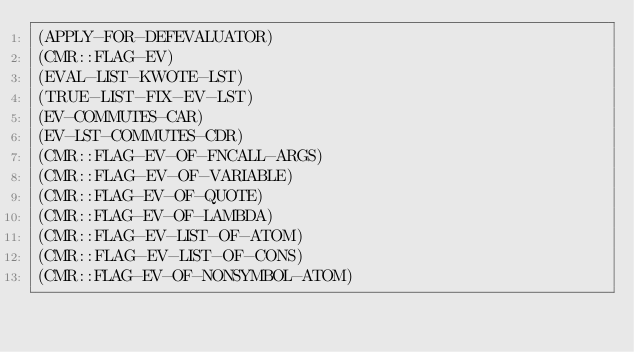<code> <loc_0><loc_0><loc_500><loc_500><_Lisp_>(APPLY-FOR-DEFEVALUATOR)
(CMR::FLAG-EV)
(EVAL-LIST-KWOTE-LST)
(TRUE-LIST-FIX-EV-LST)
(EV-COMMUTES-CAR)
(EV-LST-COMMUTES-CDR)
(CMR::FLAG-EV-OF-FNCALL-ARGS)
(CMR::FLAG-EV-OF-VARIABLE)
(CMR::FLAG-EV-OF-QUOTE)
(CMR::FLAG-EV-OF-LAMBDA)
(CMR::FLAG-EV-LIST-OF-ATOM)
(CMR::FLAG-EV-LIST-OF-CONS)
(CMR::FLAG-EV-OF-NONSYMBOL-ATOM)</code> 